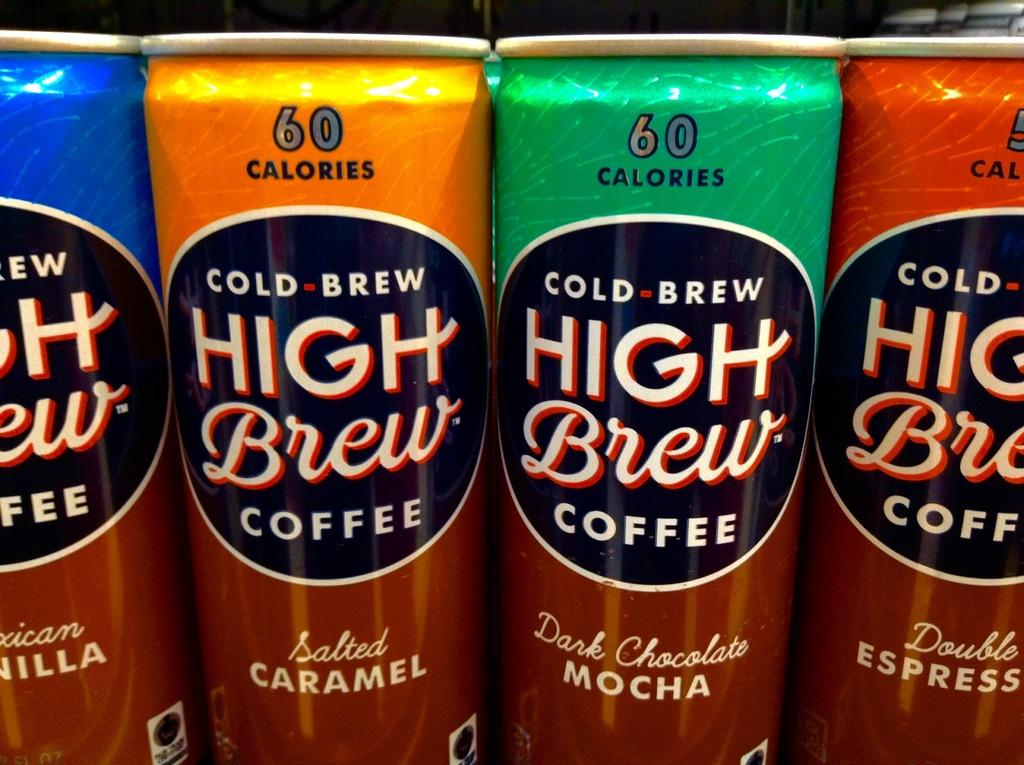<image>
Offer a succinct explanation of the picture presented. Four cans of cold brew branded high brew branded coffee. 